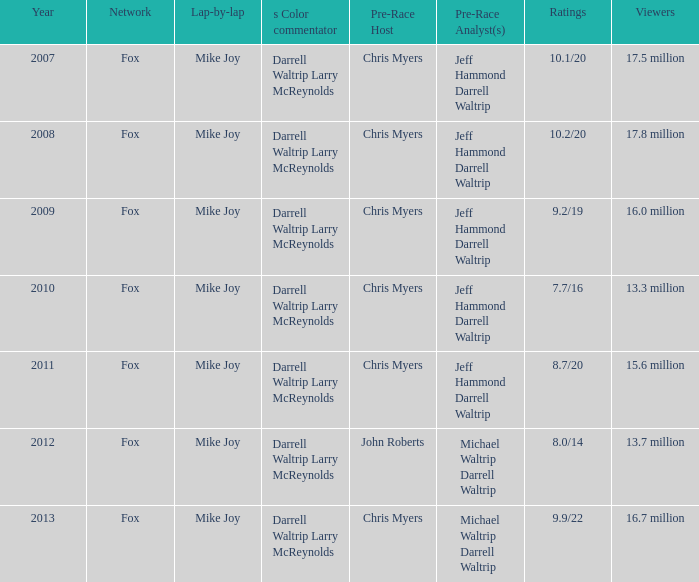9/22 as its ratings? Mike Joy. 